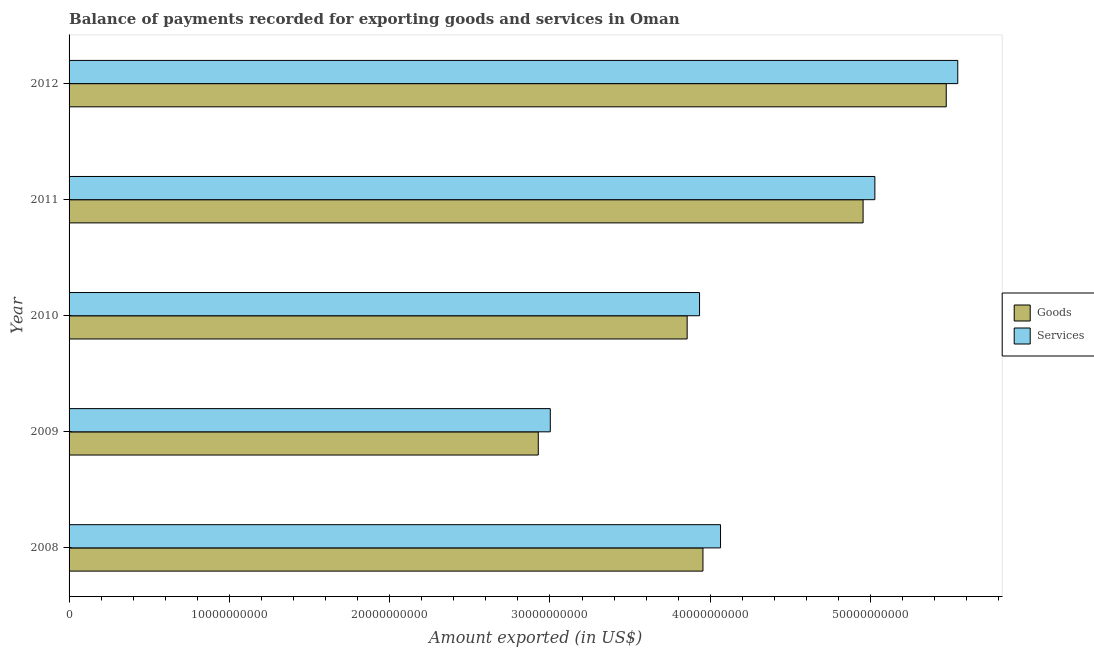How many different coloured bars are there?
Ensure brevity in your answer.  2. Are the number of bars per tick equal to the number of legend labels?
Make the answer very short. Yes. How many bars are there on the 4th tick from the top?
Your answer should be compact. 2. How many bars are there on the 5th tick from the bottom?
Provide a succinct answer. 2. What is the label of the 2nd group of bars from the top?
Make the answer very short. 2011. In how many cases, is the number of bars for a given year not equal to the number of legend labels?
Ensure brevity in your answer.  0. What is the amount of services exported in 2008?
Provide a succinct answer. 4.06e+1. Across all years, what is the maximum amount of goods exported?
Your response must be concise. 5.47e+1. Across all years, what is the minimum amount of goods exported?
Ensure brevity in your answer.  2.93e+1. In which year was the amount of services exported maximum?
Keep it short and to the point. 2012. In which year was the amount of services exported minimum?
Offer a terse response. 2009. What is the total amount of services exported in the graph?
Keep it short and to the point. 2.16e+11. What is the difference between the amount of services exported in 2011 and that in 2012?
Make the answer very short. -5.17e+09. What is the difference between the amount of services exported in 2009 and the amount of goods exported in 2011?
Offer a terse response. -1.95e+1. What is the average amount of services exported per year?
Provide a short and direct response. 4.31e+1. In the year 2008, what is the difference between the amount of services exported and amount of goods exported?
Your response must be concise. 1.10e+09. In how many years, is the amount of goods exported greater than 52000000000 US$?
Offer a very short reply. 1. What is the ratio of the amount of goods exported in 2008 to that in 2009?
Provide a succinct answer. 1.35. Is the amount of services exported in 2011 less than that in 2012?
Your answer should be compact. Yes. Is the difference between the amount of goods exported in 2010 and 2012 greater than the difference between the amount of services exported in 2010 and 2012?
Offer a terse response. No. What is the difference between the highest and the second highest amount of goods exported?
Your response must be concise. 5.19e+09. What is the difference between the highest and the lowest amount of services exported?
Your answer should be compact. 2.54e+1. In how many years, is the amount of goods exported greater than the average amount of goods exported taken over all years?
Make the answer very short. 2. Is the sum of the amount of services exported in 2008 and 2011 greater than the maximum amount of goods exported across all years?
Make the answer very short. Yes. What does the 1st bar from the top in 2011 represents?
Keep it short and to the point. Services. What does the 2nd bar from the bottom in 2008 represents?
Your answer should be compact. Services. How many years are there in the graph?
Your answer should be compact. 5. Are the values on the major ticks of X-axis written in scientific E-notation?
Ensure brevity in your answer.  No. Does the graph contain any zero values?
Keep it short and to the point. No. Where does the legend appear in the graph?
Offer a terse response. Center right. How are the legend labels stacked?
Provide a succinct answer. Vertical. What is the title of the graph?
Ensure brevity in your answer.  Balance of payments recorded for exporting goods and services in Oman. What is the label or title of the X-axis?
Offer a very short reply. Amount exported (in US$). What is the Amount exported (in US$) of Goods in 2008?
Ensure brevity in your answer.  3.95e+1. What is the Amount exported (in US$) of Services in 2008?
Keep it short and to the point. 4.06e+1. What is the Amount exported (in US$) in Goods in 2009?
Offer a very short reply. 2.93e+1. What is the Amount exported (in US$) of Services in 2009?
Your response must be concise. 3.00e+1. What is the Amount exported (in US$) of Goods in 2010?
Provide a short and direct response. 3.86e+1. What is the Amount exported (in US$) of Services in 2010?
Offer a terse response. 3.93e+1. What is the Amount exported (in US$) in Goods in 2011?
Ensure brevity in your answer.  4.95e+1. What is the Amount exported (in US$) of Services in 2011?
Ensure brevity in your answer.  5.03e+1. What is the Amount exported (in US$) of Goods in 2012?
Your response must be concise. 5.47e+1. What is the Amount exported (in US$) of Services in 2012?
Keep it short and to the point. 5.54e+1. Across all years, what is the maximum Amount exported (in US$) in Goods?
Your answer should be very brief. 5.47e+1. Across all years, what is the maximum Amount exported (in US$) in Services?
Offer a very short reply. 5.54e+1. Across all years, what is the minimum Amount exported (in US$) in Goods?
Provide a succinct answer. 2.93e+1. Across all years, what is the minimum Amount exported (in US$) in Services?
Make the answer very short. 3.00e+1. What is the total Amount exported (in US$) in Goods in the graph?
Provide a succinct answer. 2.12e+11. What is the total Amount exported (in US$) of Services in the graph?
Give a very brief answer. 2.16e+11. What is the difference between the Amount exported (in US$) in Goods in 2008 and that in 2009?
Ensure brevity in your answer.  1.03e+1. What is the difference between the Amount exported (in US$) of Services in 2008 and that in 2009?
Your answer should be very brief. 1.06e+1. What is the difference between the Amount exported (in US$) in Goods in 2008 and that in 2010?
Your response must be concise. 9.86e+08. What is the difference between the Amount exported (in US$) in Services in 2008 and that in 2010?
Provide a short and direct response. 1.31e+09. What is the difference between the Amount exported (in US$) in Goods in 2008 and that in 2011?
Your answer should be very brief. -9.99e+09. What is the difference between the Amount exported (in US$) in Services in 2008 and that in 2011?
Ensure brevity in your answer.  -9.63e+09. What is the difference between the Amount exported (in US$) in Goods in 2008 and that in 2012?
Your answer should be very brief. -1.52e+1. What is the difference between the Amount exported (in US$) of Services in 2008 and that in 2012?
Offer a terse response. -1.48e+1. What is the difference between the Amount exported (in US$) of Goods in 2009 and that in 2010?
Provide a short and direct response. -9.29e+09. What is the difference between the Amount exported (in US$) of Services in 2009 and that in 2010?
Offer a very short reply. -9.31e+09. What is the difference between the Amount exported (in US$) of Goods in 2009 and that in 2011?
Offer a very short reply. -2.03e+1. What is the difference between the Amount exported (in US$) of Services in 2009 and that in 2011?
Your answer should be very brief. -2.02e+1. What is the difference between the Amount exported (in US$) of Goods in 2009 and that in 2012?
Provide a short and direct response. -2.55e+1. What is the difference between the Amount exported (in US$) in Services in 2009 and that in 2012?
Ensure brevity in your answer.  -2.54e+1. What is the difference between the Amount exported (in US$) of Goods in 2010 and that in 2011?
Provide a succinct answer. -1.10e+1. What is the difference between the Amount exported (in US$) of Services in 2010 and that in 2011?
Ensure brevity in your answer.  -1.09e+1. What is the difference between the Amount exported (in US$) of Goods in 2010 and that in 2012?
Offer a terse response. -1.62e+1. What is the difference between the Amount exported (in US$) in Services in 2010 and that in 2012?
Your response must be concise. -1.61e+1. What is the difference between the Amount exported (in US$) of Goods in 2011 and that in 2012?
Your response must be concise. -5.19e+09. What is the difference between the Amount exported (in US$) of Services in 2011 and that in 2012?
Provide a short and direct response. -5.17e+09. What is the difference between the Amount exported (in US$) in Goods in 2008 and the Amount exported (in US$) in Services in 2009?
Offer a very short reply. 9.52e+09. What is the difference between the Amount exported (in US$) in Goods in 2008 and the Amount exported (in US$) in Services in 2010?
Your response must be concise. 2.13e+08. What is the difference between the Amount exported (in US$) in Goods in 2008 and the Amount exported (in US$) in Services in 2011?
Your answer should be compact. -1.07e+1. What is the difference between the Amount exported (in US$) in Goods in 2008 and the Amount exported (in US$) in Services in 2012?
Your answer should be very brief. -1.59e+1. What is the difference between the Amount exported (in US$) in Goods in 2009 and the Amount exported (in US$) in Services in 2010?
Make the answer very short. -1.01e+1. What is the difference between the Amount exported (in US$) in Goods in 2009 and the Amount exported (in US$) in Services in 2011?
Ensure brevity in your answer.  -2.10e+1. What is the difference between the Amount exported (in US$) of Goods in 2009 and the Amount exported (in US$) of Services in 2012?
Offer a terse response. -2.62e+1. What is the difference between the Amount exported (in US$) in Goods in 2010 and the Amount exported (in US$) in Services in 2011?
Your response must be concise. -1.17e+1. What is the difference between the Amount exported (in US$) of Goods in 2010 and the Amount exported (in US$) of Services in 2012?
Offer a terse response. -1.69e+1. What is the difference between the Amount exported (in US$) in Goods in 2011 and the Amount exported (in US$) in Services in 2012?
Your answer should be very brief. -5.91e+09. What is the average Amount exported (in US$) of Goods per year?
Your response must be concise. 4.23e+1. What is the average Amount exported (in US$) of Services per year?
Your answer should be compact. 4.31e+1. In the year 2008, what is the difference between the Amount exported (in US$) in Goods and Amount exported (in US$) in Services?
Make the answer very short. -1.10e+09. In the year 2009, what is the difference between the Amount exported (in US$) of Goods and Amount exported (in US$) of Services?
Offer a terse response. -7.49e+08. In the year 2010, what is the difference between the Amount exported (in US$) of Goods and Amount exported (in US$) of Services?
Ensure brevity in your answer.  -7.73e+08. In the year 2011, what is the difference between the Amount exported (in US$) in Goods and Amount exported (in US$) in Services?
Give a very brief answer. -7.34e+08. In the year 2012, what is the difference between the Amount exported (in US$) in Goods and Amount exported (in US$) in Services?
Give a very brief answer. -7.18e+08. What is the ratio of the Amount exported (in US$) of Goods in 2008 to that in 2009?
Make the answer very short. 1.35. What is the ratio of the Amount exported (in US$) of Services in 2008 to that in 2009?
Your answer should be compact. 1.35. What is the ratio of the Amount exported (in US$) of Goods in 2008 to that in 2010?
Provide a short and direct response. 1.03. What is the ratio of the Amount exported (in US$) of Goods in 2008 to that in 2011?
Your response must be concise. 0.8. What is the ratio of the Amount exported (in US$) of Services in 2008 to that in 2011?
Provide a succinct answer. 0.81. What is the ratio of the Amount exported (in US$) in Goods in 2008 to that in 2012?
Your response must be concise. 0.72. What is the ratio of the Amount exported (in US$) of Services in 2008 to that in 2012?
Give a very brief answer. 0.73. What is the ratio of the Amount exported (in US$) of Goods in 2009 to that in 2010?
Provide a short and direct response. 0.76. What is the ratio of the Amount exported (in US$) in Services in 2009 to that in 2010?
Offer a terse response. 0.76. What is the ratio of the Amount exported (in US$) in Goods in 2009 to that in 2011?
Your answer should be very brief. 0.59. What is the ratio of the Amount exported (in US$) of Services in 2009 to that in 2011?
Make the answer very short. 0.6. What is the ratio of the Amount exported (in US$) of Goods in 2009 to that in 2012?
Ensure brevity in your answer.  0.53. What is the ratio of the Amount exported (in US$) in Services in 2009 to that in 2012?
Give a very brief answer. 0.54. What is the ratio of the Amount exported (in US$) in Goods in 2010 to that in 2011?
Make the answer very short. 0.78. What is the ratio of the Amount exported (in US$) of Services in 2010 to that in 2011?
Provide a succinct answer. 0.78. What is the ratio of the Amount exported (in US$) in Goods in 2010 to that in 2012?
Offer a terse response. 0.7. What is the ratio of the Amount exported (in US$) in Services in 2010 to that in 2012?
Offer a terse response. 0.71. What is the ratio of the Amount exported (in US$) of Goods in 2011 to that in 2012?
Keep it short and to the point. 0.91. What is the ratio of the Amount exported (in US$) of Services in 2011 to that in 2012?
Make the answer very short. 0.91. What is the difference between the highest and the second highest Amount exported (in US$) in Goods?
Offer a very short reply. 5.19e+09. What is the difference between the highest and the second highest Amount exported (in US$) of Services?
Give a very brief answer. 5.17e+09. What is the difference between the highest and the lowest Amount exported (in US$) in Goods?
Ensure brevity in your answer.  2.55e+1. What is the difference between the highest and the lowest Amount exported (in US$) of Services?
Provide a short and direct response. 2.54e+1. 